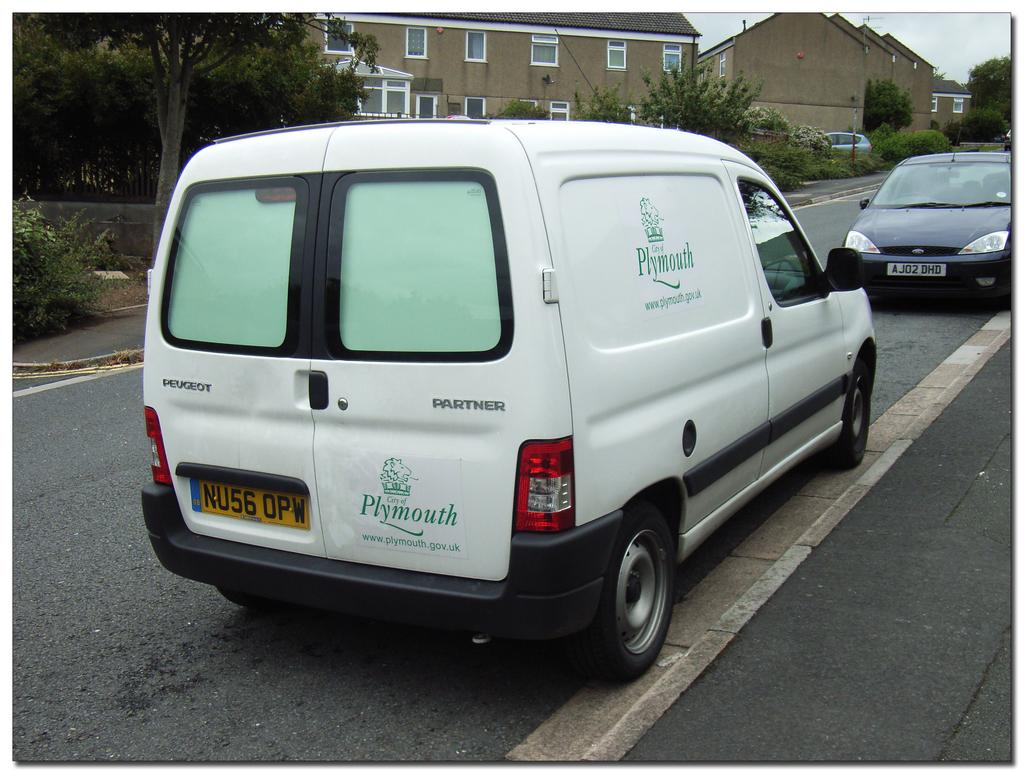<image>
Write a terse but informative summary of the picture. A white Plymouth government van parked on a suburban street. 